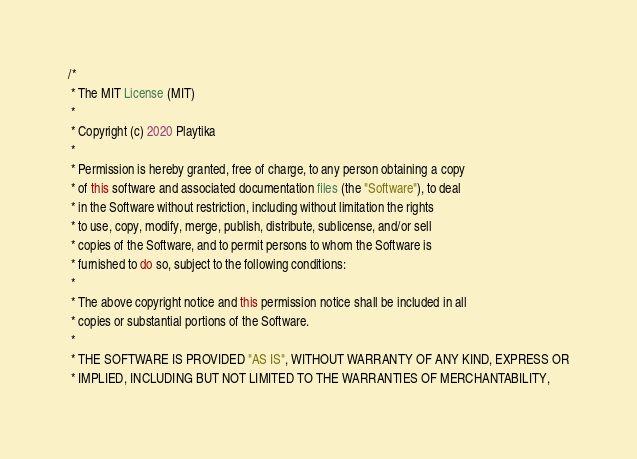<code> <loc_0><loc_0><loc_500><loc_500><_Java_>/*
 * The MIT License (MIT)
 *
 * Copyright (c) 2020 Playtika
 *
 * Permission is hereby granted, free of charge, to any person obtaining a copy
 * of this software and associated documentation files (the "Software"), to deal
 * in the Software without restriction, including without limitation the rights
 * to use, copy, modify, merge, publish, distribute, sublicense, and/or sell
 * copies of the Software, and to permit persons to whom the Software is
 * furnished to do so, subject to the following conditions:
 *
 * The above copyright notice and this permission notice shall be included in all
 * copies or substantial portions of the Software.
 *
 * THE SOFTWARE IS PROVIDED "AS IS", WITHOUT WARRANTY OF ANY KIND, EXPRESS OR
 * IMPLIED, INCLUDING BUT NOT LIMITED TO THE WARRANTIES OF MERCHANTABILITY,</code> 